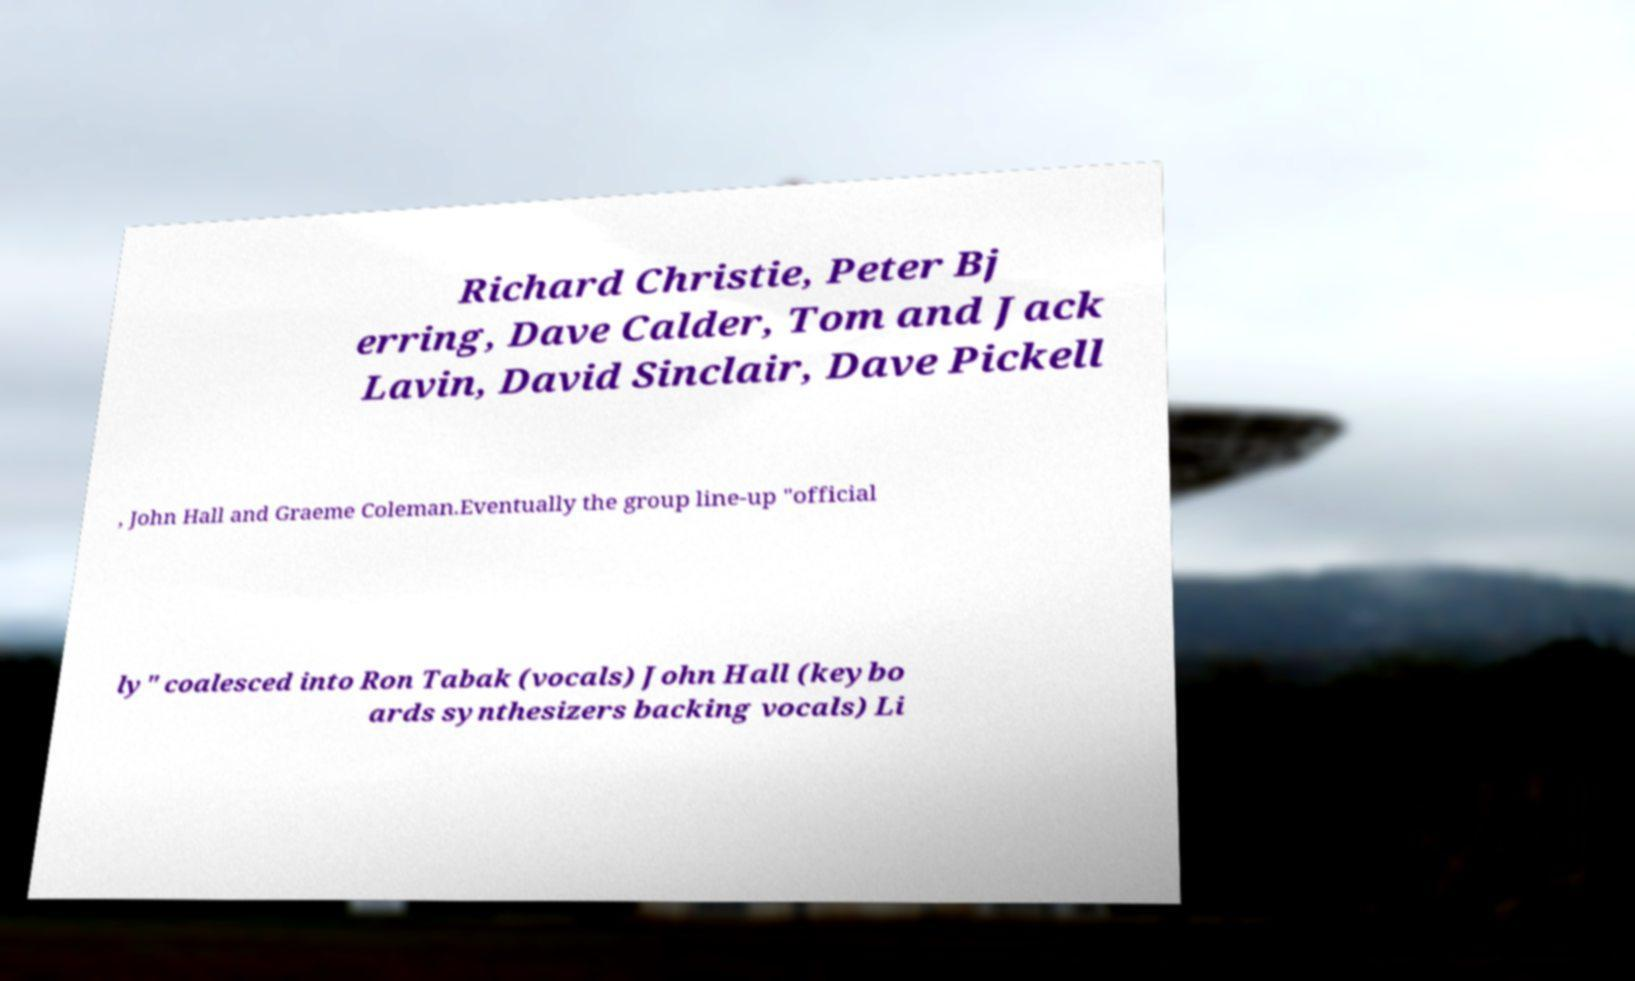Can you read and provide the text displayed in the image?This photo seems to have some interesting text. Can you extract and type it out for me? Richard Christie, Peter Bj erring, Dave Calder, Tom and Jack Lavin, David Sinclair, Dave Pickell , John Hall and Graeme Coleman.Eventually the group line-up "official ly" coalesced into Ron Tabak (vocals) John Hall (keybo ards synthesizers backing vocals) Li 